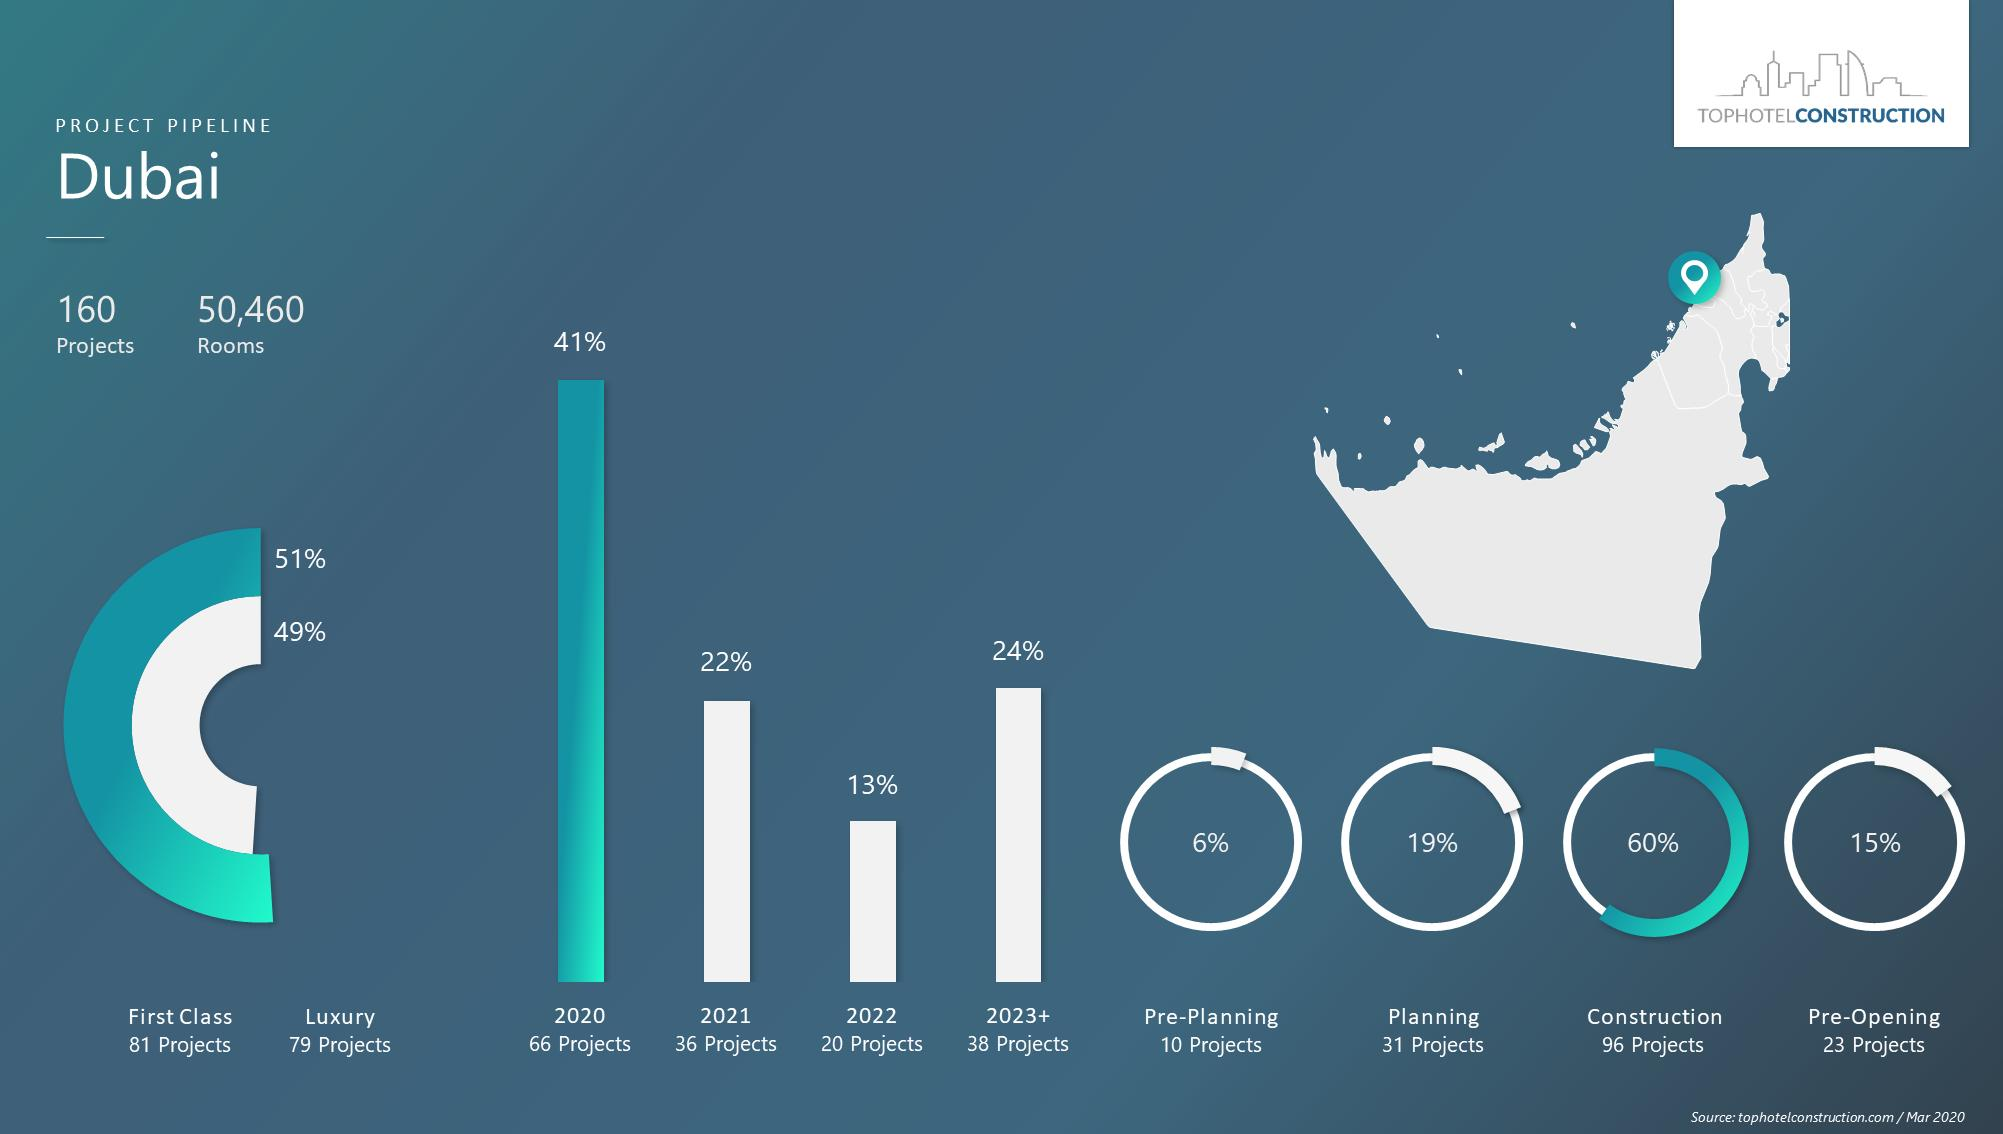Point out several critical features in this image. The number of projects in 2022 is expected to be low. 79% of the projects are luxury projects. According to the given data, approximately 19% of planning projects are completed on time. Approximately 6% of projects are planned before beginning. In 2020, there were a large number of projects. 